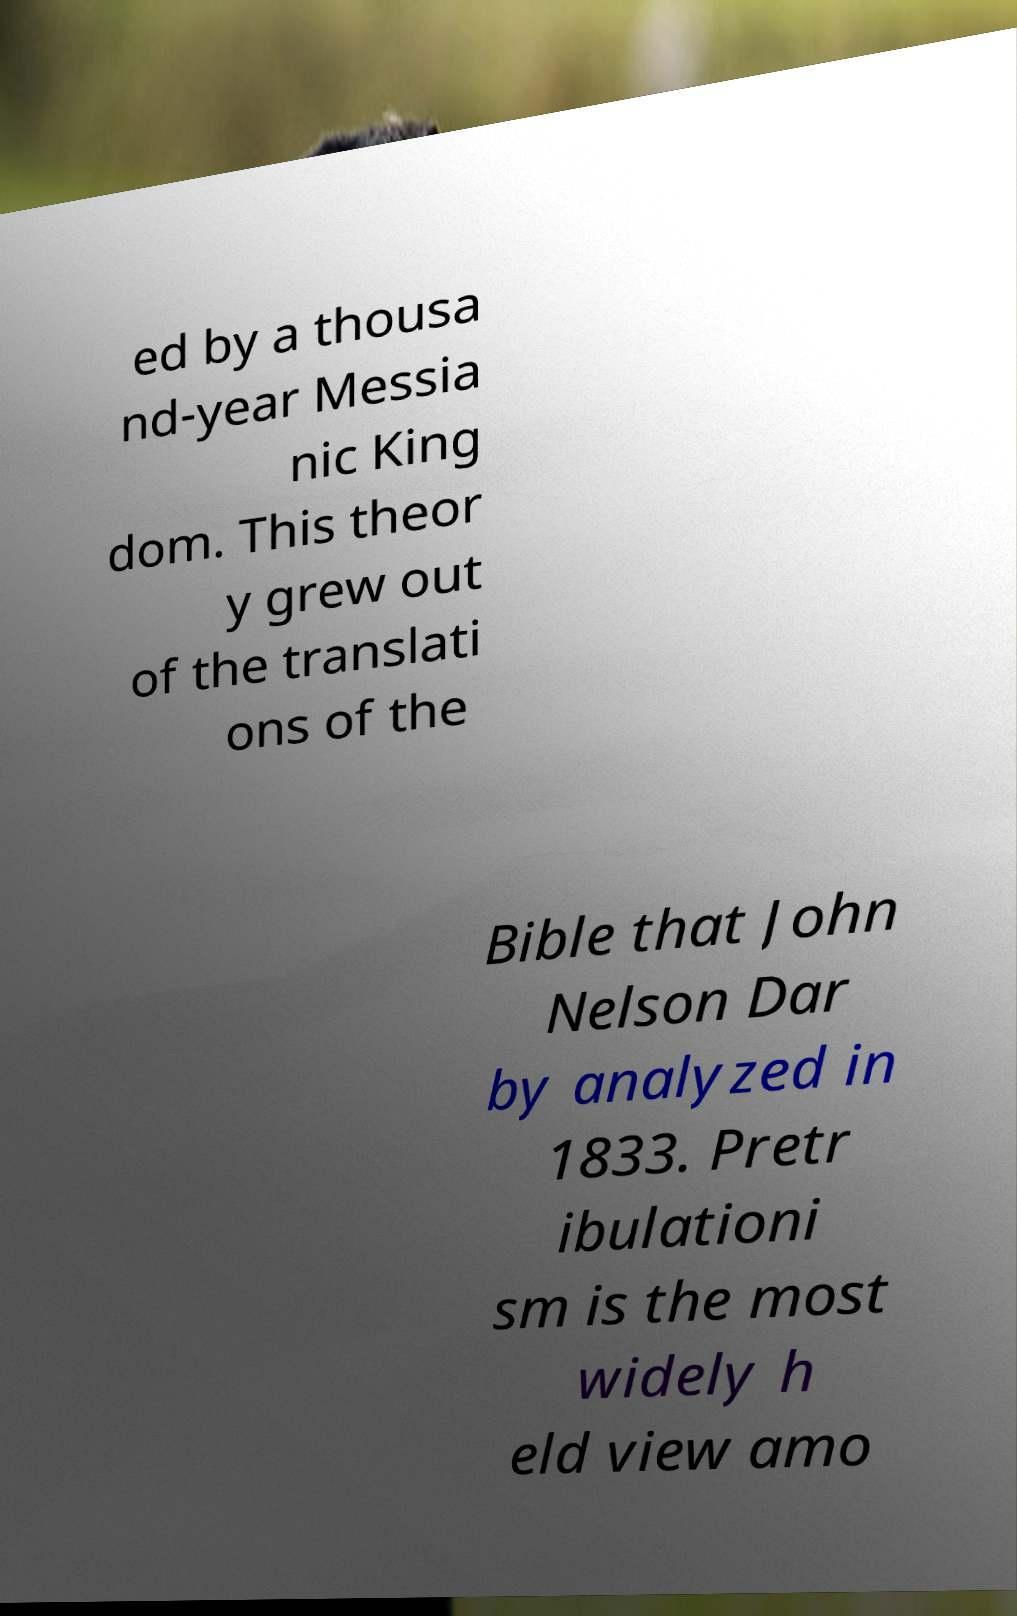I need the written content from this picture converted into text. Can you do that? ed by a thousa nd-year Messia nic King dom. This theor y grew out of the translati ons of the Bible that John Nelson Dar by analyzed in 1833. Pretr ibulationi sm is the most widely h eld view amo 